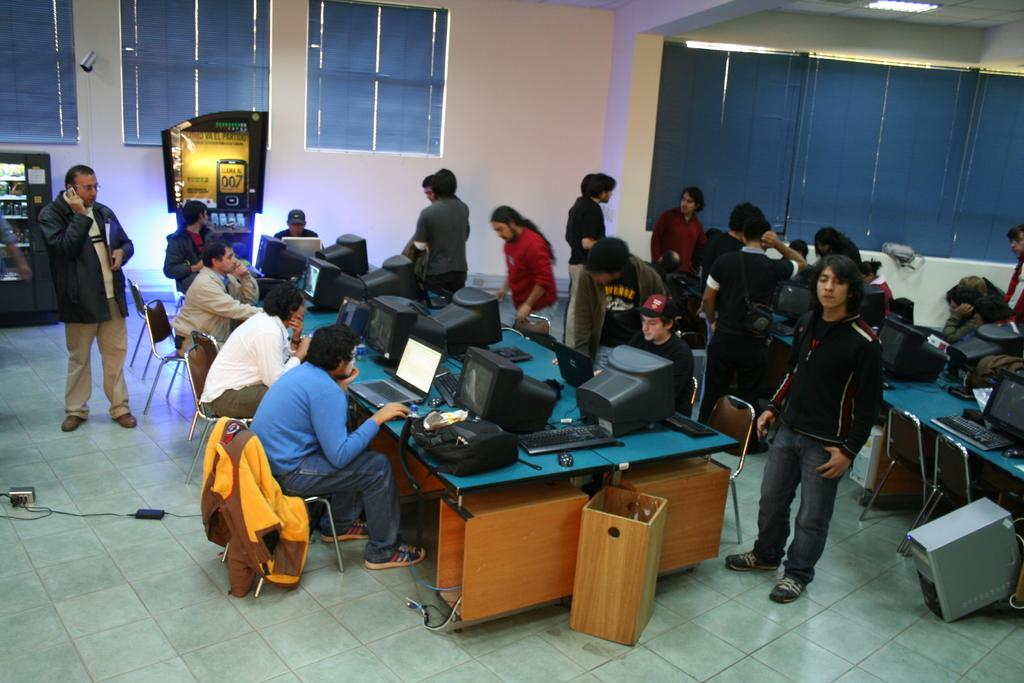How many people are in the image? There is a group of people in the image. What are some of the people doing in the image? Some of the people are sitting, working on laptops, and working on computer systems. Are there any people standing in the image? Yes, there are a couple of people standing in the image. What can be seen in the background of the image? There is a window in the background of the image. What type of shop can be seen in the image? There is no shop present in the image; it features a group of people working and standing. Who is the judge in the image? There is no judge present in the image. 